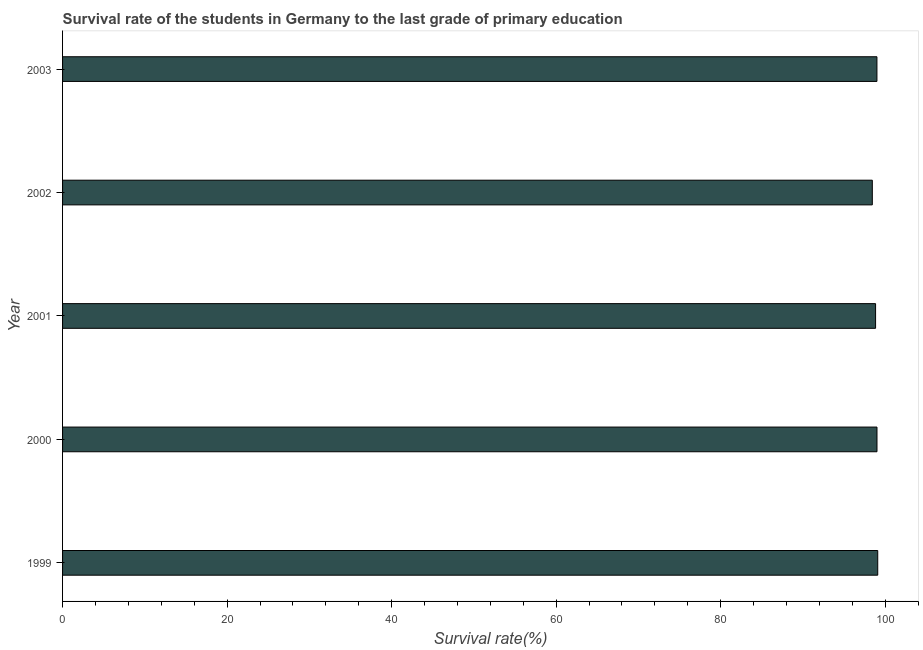Does the graph contain any zero values?
Keep it short and to the point. No. Does the graph contain grids?
Give a very brief answer. No. What is the title of the graph?
Offer a very short reply. Survival rate of the students in Germany to the last grade of primary education. What is the label or title of the X-axis?
Your answer should be compact. Survival rate(%). What is the survival rate in primary education in 1999?
Ensure brevity in your answer.  99.09. Across all years, what is the maximum survival rate in primary education?
Your answer should be compact. 99.09. Across all years, what is the minimum survival rate in primary education?
Keep it short and to the point. 98.43. In which year was the survival rate in primary education maximum?
Provide a succinct answer. 1999. What is the sum of the survival rate in primary education?
Offer a terse response. 494.35. What is the difference between the survival rate in primary education in 1999 and 2002?
Provide a succinct answer. 0.66. What is the average survival rate in primary education per year?
Your response must be concise. 98.87. What is the median survival rate in primary education?
Your response must be concise. 99. In how many years, is the survival rate in primary education greater than 64 %?
Your response must be concise. 5. What is the ratio of the survival rate in primary education in 2001 to that in 2003?
Provide a short and direct response. 1. Is the difference between the survival rate in primary education in 1999 and 2002 greater than the difference between any two years?
Your answer should be very brief. Yes. What is the difference between the highest and the second highest survival rate in primary education?
Provide a short and direct response. 0.09. Is the sum of the survival rate in primary education in 1999 and 2001 greater than the maximum survival rate in primary education across all years?
Give a very brief answer. Yes. What is the difference between the highest and the lowest survival rate in primary education?
Provide a succinct answer. 0.66. In how many years, is the survival rate in primary education greater than the average survival rate in primary education taken over all years?
Ensure brevity in your answer.  3. Are the values on the major ticks of X-axis written in scientific E-notation?
Offer a terse response. No. What is the Survival rate(%) in 1999?
Provide a succinct answer. 99.09. What is the Survival rate(%) of 2000?
Provide a short and direct response. 99. What is the Survival rate(%) in 2001?
Your answer should be very brief. 98.83. What is the Survival rate(%) in 2002?
Your response must be concise. 98.43. What is the Survival rate(%) of 2003?
Give a very brief answer. 99. What is the difference between the Survival rate(%) in 1999 and 2000?
Offer a terse response. 0.09. What is the difference between the Survival rate(%) in 1999 and 2001?
Provide a short and direct response. 0.26. What is the difference between the Survival rate(%) in 1999 and 2002?
Your answer should be compact. 0.66. What is the difference between the Survival rate(%) in 1999 and 2003?
Offer a terse response. 0.1. What is the difference between the Survival rate(%) in 2000 and 2001?
Make the answer very short. 0.17. What is the difference between the Survival rate(%) in 2000 and 2002?
Offer a terse response. 0.57. What is the difference between the Survival rate(%) in 2000 and 2003?
Ensure brevity in your answer.  0.01. What is the difference between the Survival rate(%) in 2001 and 2002?
Make the answer very short. 0.4. What is the difference between the Survival rate(%) in 2001 and 2003?
Offer a terse response. -0.16. What is the difference between the Survival rate(%) in 2002 and 2003?
Offer a very short reply. -0.56. What is the ratio of the Survival rate(%) in 1999 to that in 2000?
Provide a short and direct response. 1. What is the ratio of the Survival rate(%) in 1999 to that in 2002?
Your answer should be very brief. 1.01. What is the ratio of the Survival rate(%) in 1999 to that in 2003?
Ensure brevity in your answer.  1. What is the ratio of the Survival rate(%) in 2000 to that in 2001?
Ensure brevity in your answer.  1. What is the ratio of the Survival rate(%) in 2001 to that in 2003?
Provide a short and direct response. 1. What is the ratio of the Survival rate(%) in 2002 to that in 2003?
Offer a very short reply. 0.99. 